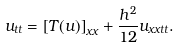<formula> <loc_0><loc_0><loc_500><loc_500>u _ { t t } = \left [ T ( u ) \right ] _ { x x } + \frac { h ^ { 2 } } { 1 2 } u _ { x x t t } .</formula> 